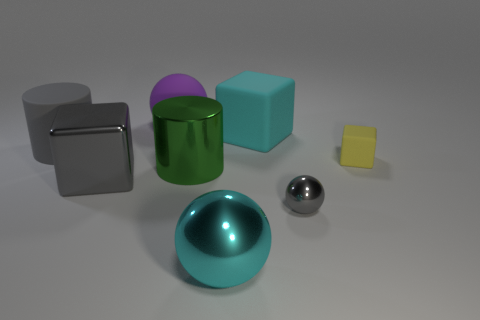Subtract all gray metallic blocks. How many blocks are left? 2 Add 2 objects. How many objects exist? 10 Subtract all gray cylinders. How many cylinders are left? 1 Subtract 2 balls. How many balls are left? 1 Subtract all big green objects. Subtract all yellow cubes. How many objects are left? 6 Add 5 tiny gray metallic objects. How many tiny gray metallic objects are left? 6 Add 6 large gray metallic things. How many large gray metallic things exist? 7 Subtract 0 green spheres. How many objects are left? 8 Subtract all cubes. How many objects are left? 5 Subtract all purple cubes. Subtract all cyan balls. How many cubes are left? 3 